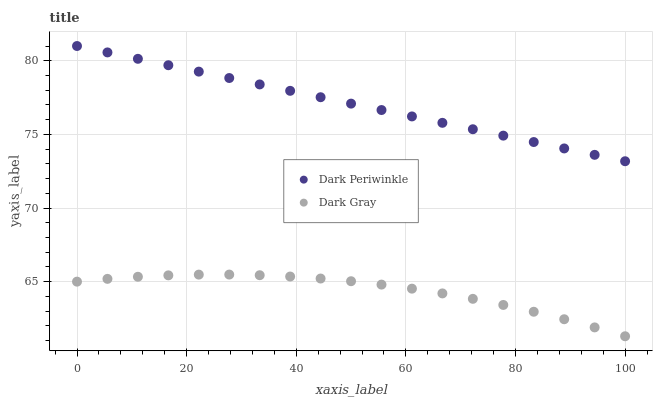Does Dark Gray have the minimum area under the curve?
Answer yes or no. Yes. Does Dark Periwinkle have the maximum area under the curve?
Answer yes or no. Yes. Does Dark Periwinkle have the minimum area under the curve?
Answer yes or no. No. Is Dark Periwinkle the smoothest?
Answer yes or no. Yes. Is Dark Gray the roughest?
Answer yes or no. Yes. Is Dark Periwinkle the roughest?
Answer yes or no. No. Does Dark Gray have the lowest value?
Answer yes or no. Yes. Does Dark Periwinkle have the lowest value?
Answer yes or no. No. Does Dark Periwinkle have the highest value?
Answer yes or no. Yes. Is Dark Gray less than Dark Periwinkle?
Answer yes or no. Yes. Is Dark Periwinkle greater than Dark Gray?
Answer yes or no. Yes. Does Dark Gray intersect Dark Periwinkle?
Answer yes or no. No. 